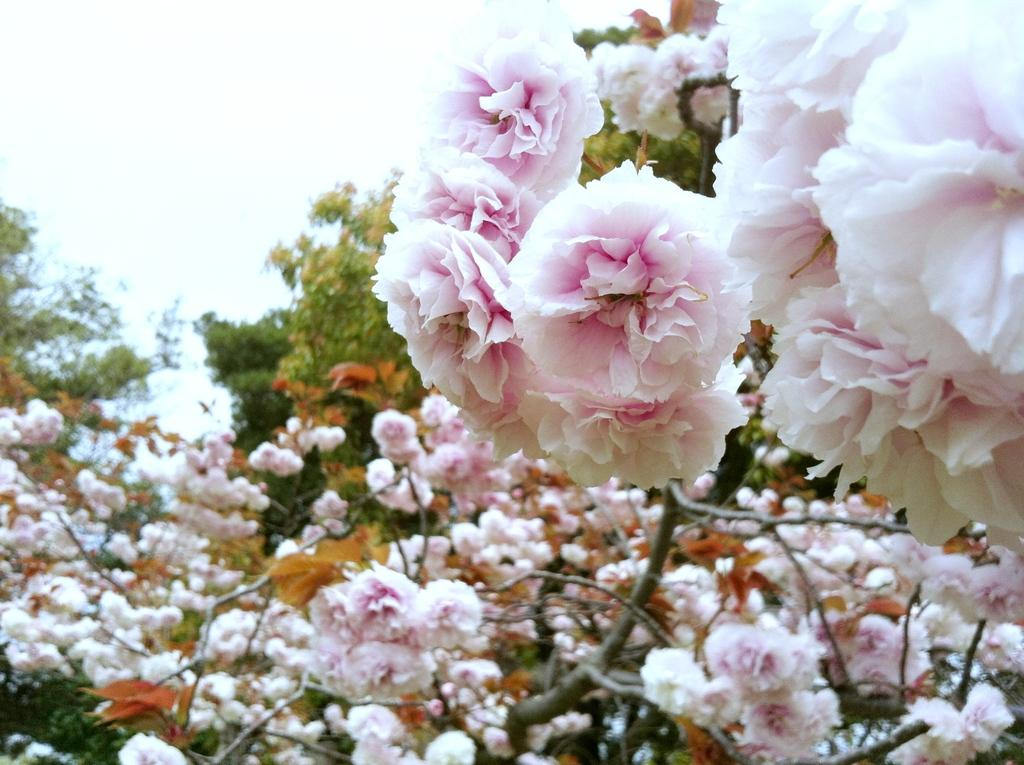What type of plants can be seen in the image? There are flowers and trees in the image. What can be seen in the background of the image? The sky is visible in the background of the image. What type of smoke can be seen coming from the manager's office in the image? There is no manager or office present in the image, so there is no smoke to be seen. 